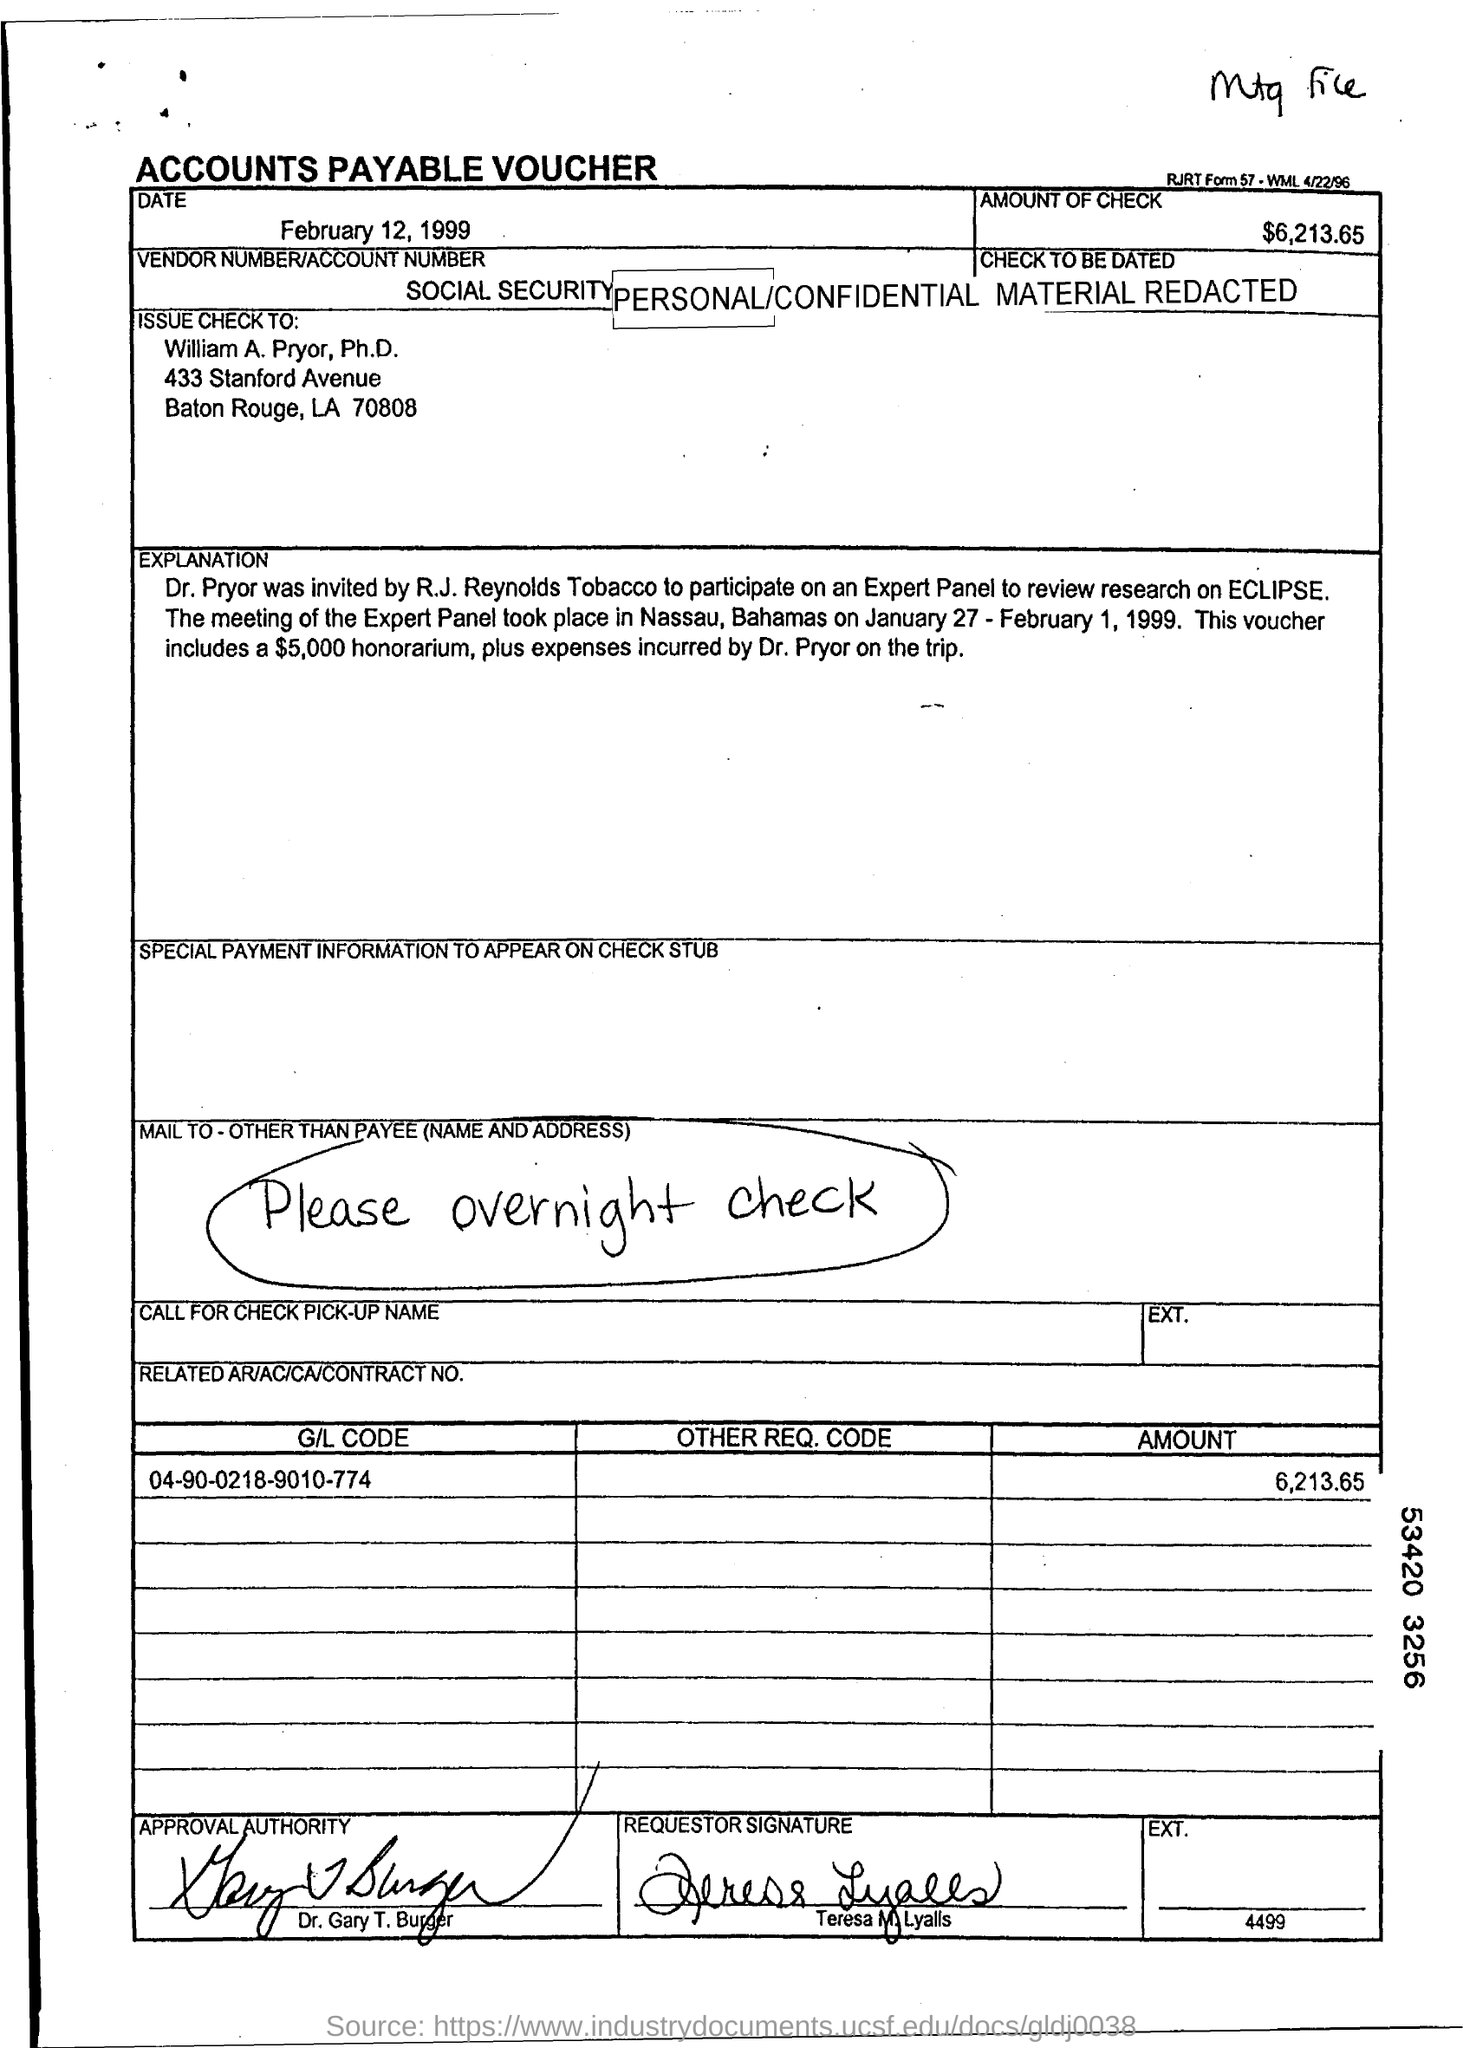Identify some key points in this picture. The date is February 12, 1999. The check is made payable to William A. Pryor, Ph.D. The requestor's name is Teresa M. Lyalls. Dr. Gary T. Burger is the approval authority. The amount of the check is $6,213.65. 